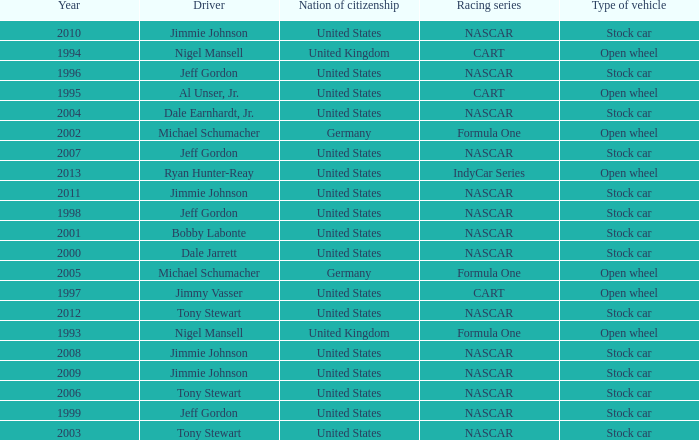What year has the vehicle of open wheel and a racing series of formula one with a Nation of citizenship in Germany. 2002, 2005. 